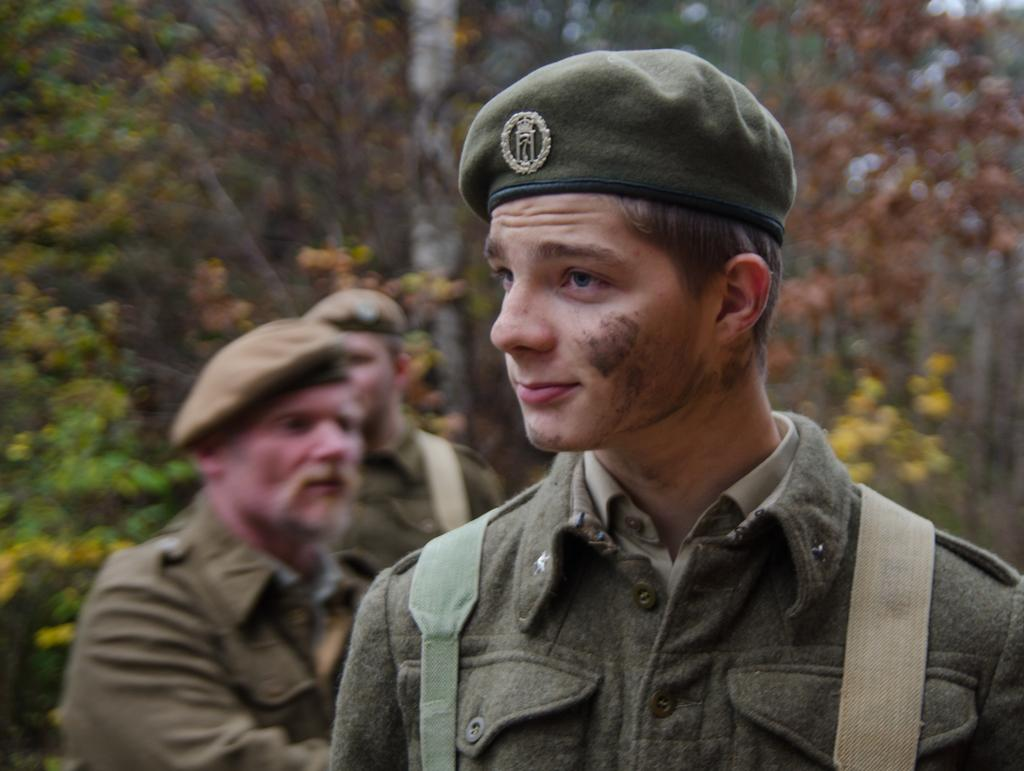Who is present in the image? There is a man standing in the image. What can be seen in the background of the image? There are trees in the background of the image. What type of drum is the man playing in the image? There is no drum present in the image; the man is simply standing. 